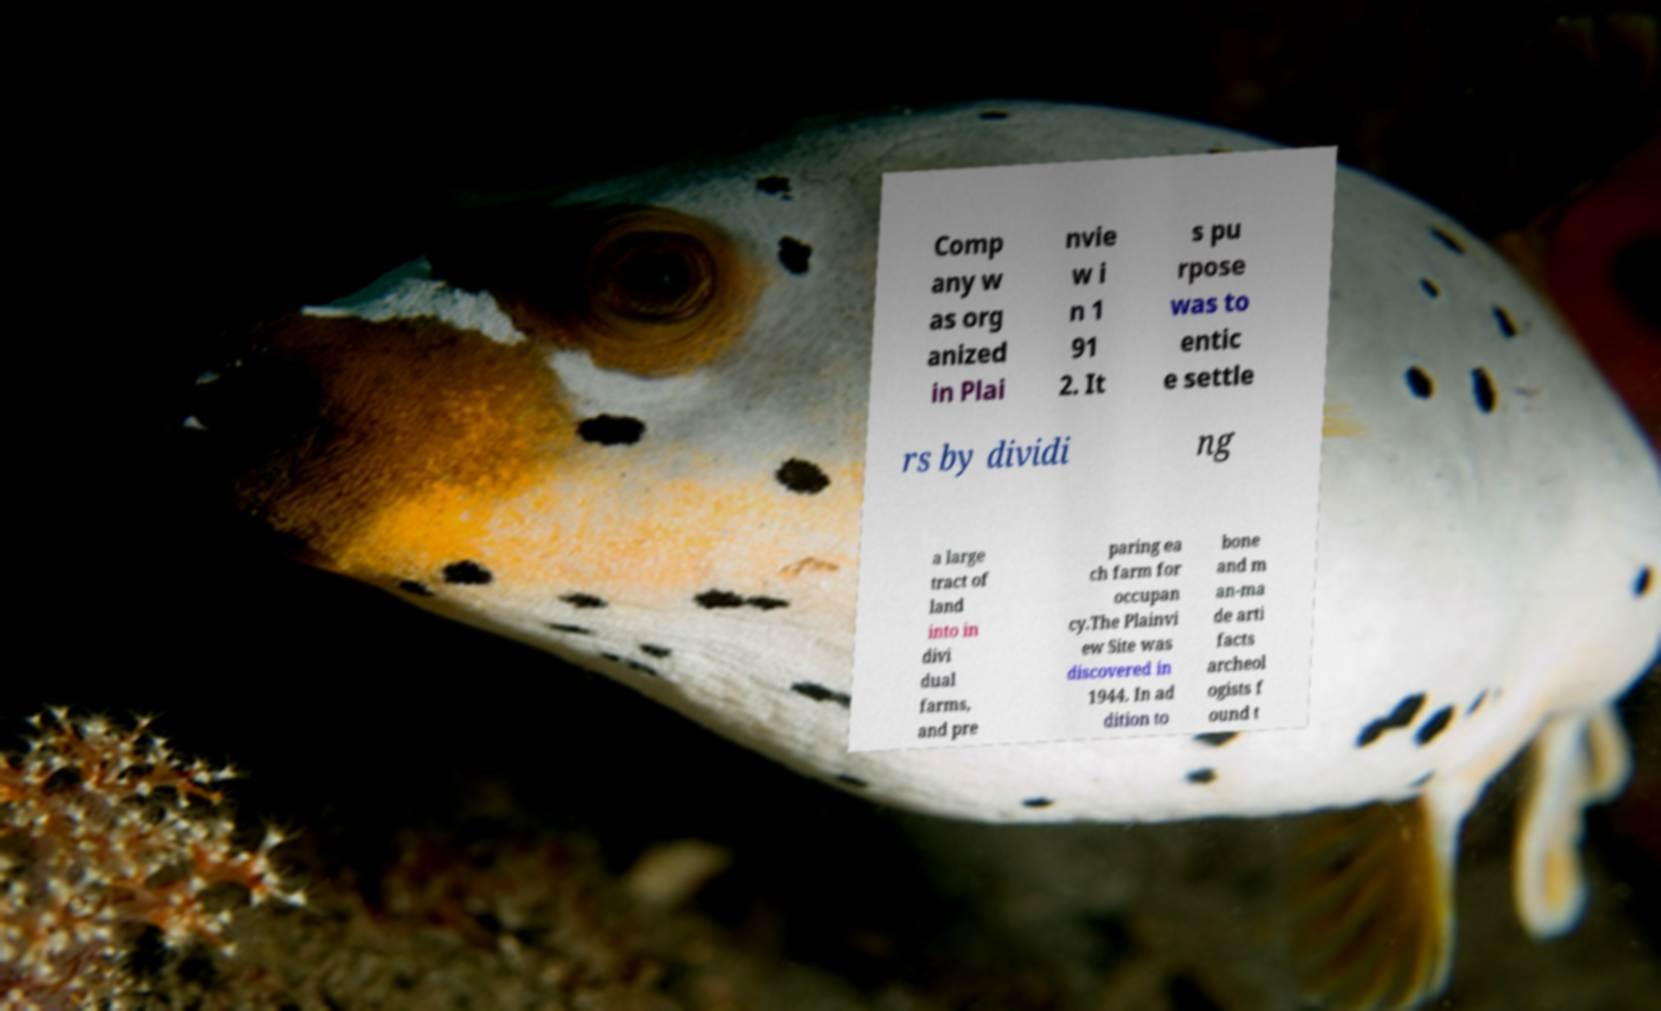Could you assist in decoding the text presented in this image and type it out clearly? Comp any w as org anized in Plai nvie w i n 1 91 2. It s pu rpose was to entic e settle rs by dividi ng a large tract of land into in divi dual farms, and pre paring ea ch farm for occupan cy.The Plainvi ew Site was discovered in 1944. In ad dition to bone and m an-ma de arti facts archeol ogists f ound t 